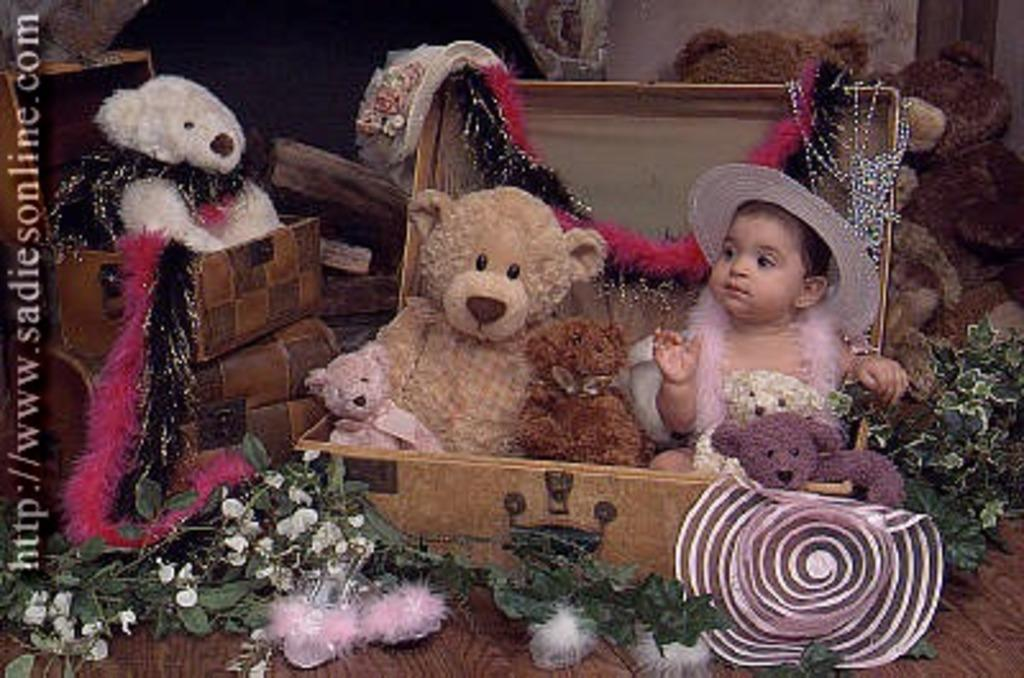What can be seen in the picture in large quantities? There are many toys in the picture. Who is present in the picture along with the toys? There is a baby present in the picture. Where is the throne located in the picture? There is no throne present in the picture. What type of harmony is being depicted in the picture? The picture does not depict any specific harmony; it simply shows a baby with many toys. 